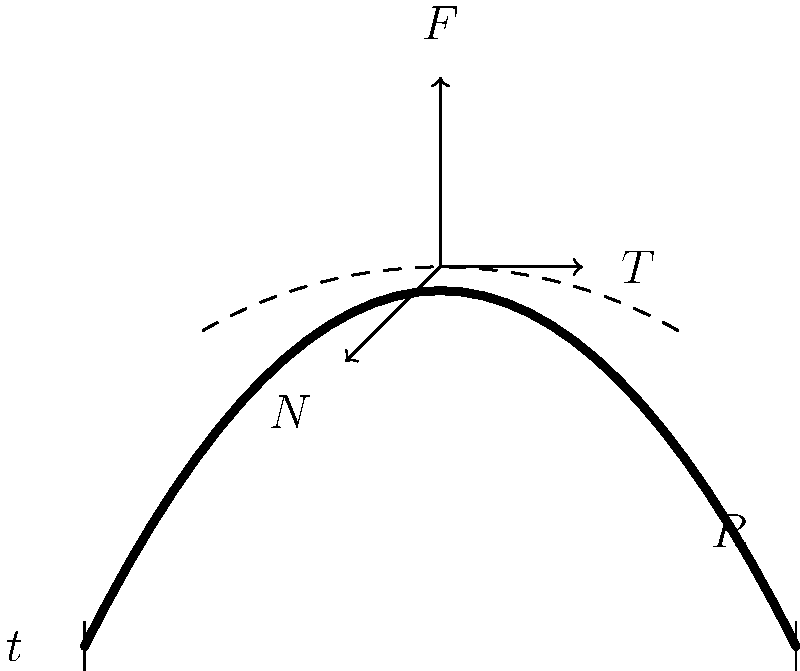In a contemporary public art installation, a curved concrete wall is subjected to various forces. Given the wall's curvature radius $R$, thickness $t$, and an applied force $F$, how does the distribution of normal stress ($\sigma$) vary across the wall's cross-section? To understand the stress distribution in the curved concrete wall, we need to follow these steps:

1. Recognize that the wall is curved, which affects stress distribution differently than in straight walls.

2. Identify the forces acting on the wall:
   - $F$: Applied external force
   - $T$: Tangential force component
   - $N$: Normal force component

3. Understand that the curvature causes an uneven stress distribution across the wall's thickness.

4. Apply the curved beam theory, which states that the normal stress $\sigma$ at any point in the cross-section is given by:

   $$\sigma = \frac{N}{A} + \frac{My}{I}$$

   Where:
   - $N$ is the normal force
   - $A$ is the cross-sectional area
   - $M$ is the bending moment
   - $y$ is the distance from the neutral axis
   - $I$ is the moment of inertia

5. Consider that in a curved beam, the neutral axis is shifted towards the center of curvature, causing:
   - Compressive stresses to increase on the concave side
   - Tensile stresses to decrease on the convex side

6. The stress distribution across the wall's thickness will be non-linear, with maximum compressive stress on the concave surface and minimum tensile stress (or possibly compressive, depending on the loading) on the convex surface.

7. The magnitude of stress variation depends on the ratio of the wall's thickness to its radius of curvature ($t/R$). A smaller ratio results in a more uniform stress distribution, while a larger ratio leads to more pronounced stress variations.
Answer: Non-linear, with higher compressive stress on the concave side and lower tensile (or compressive) stress on the convex side. 